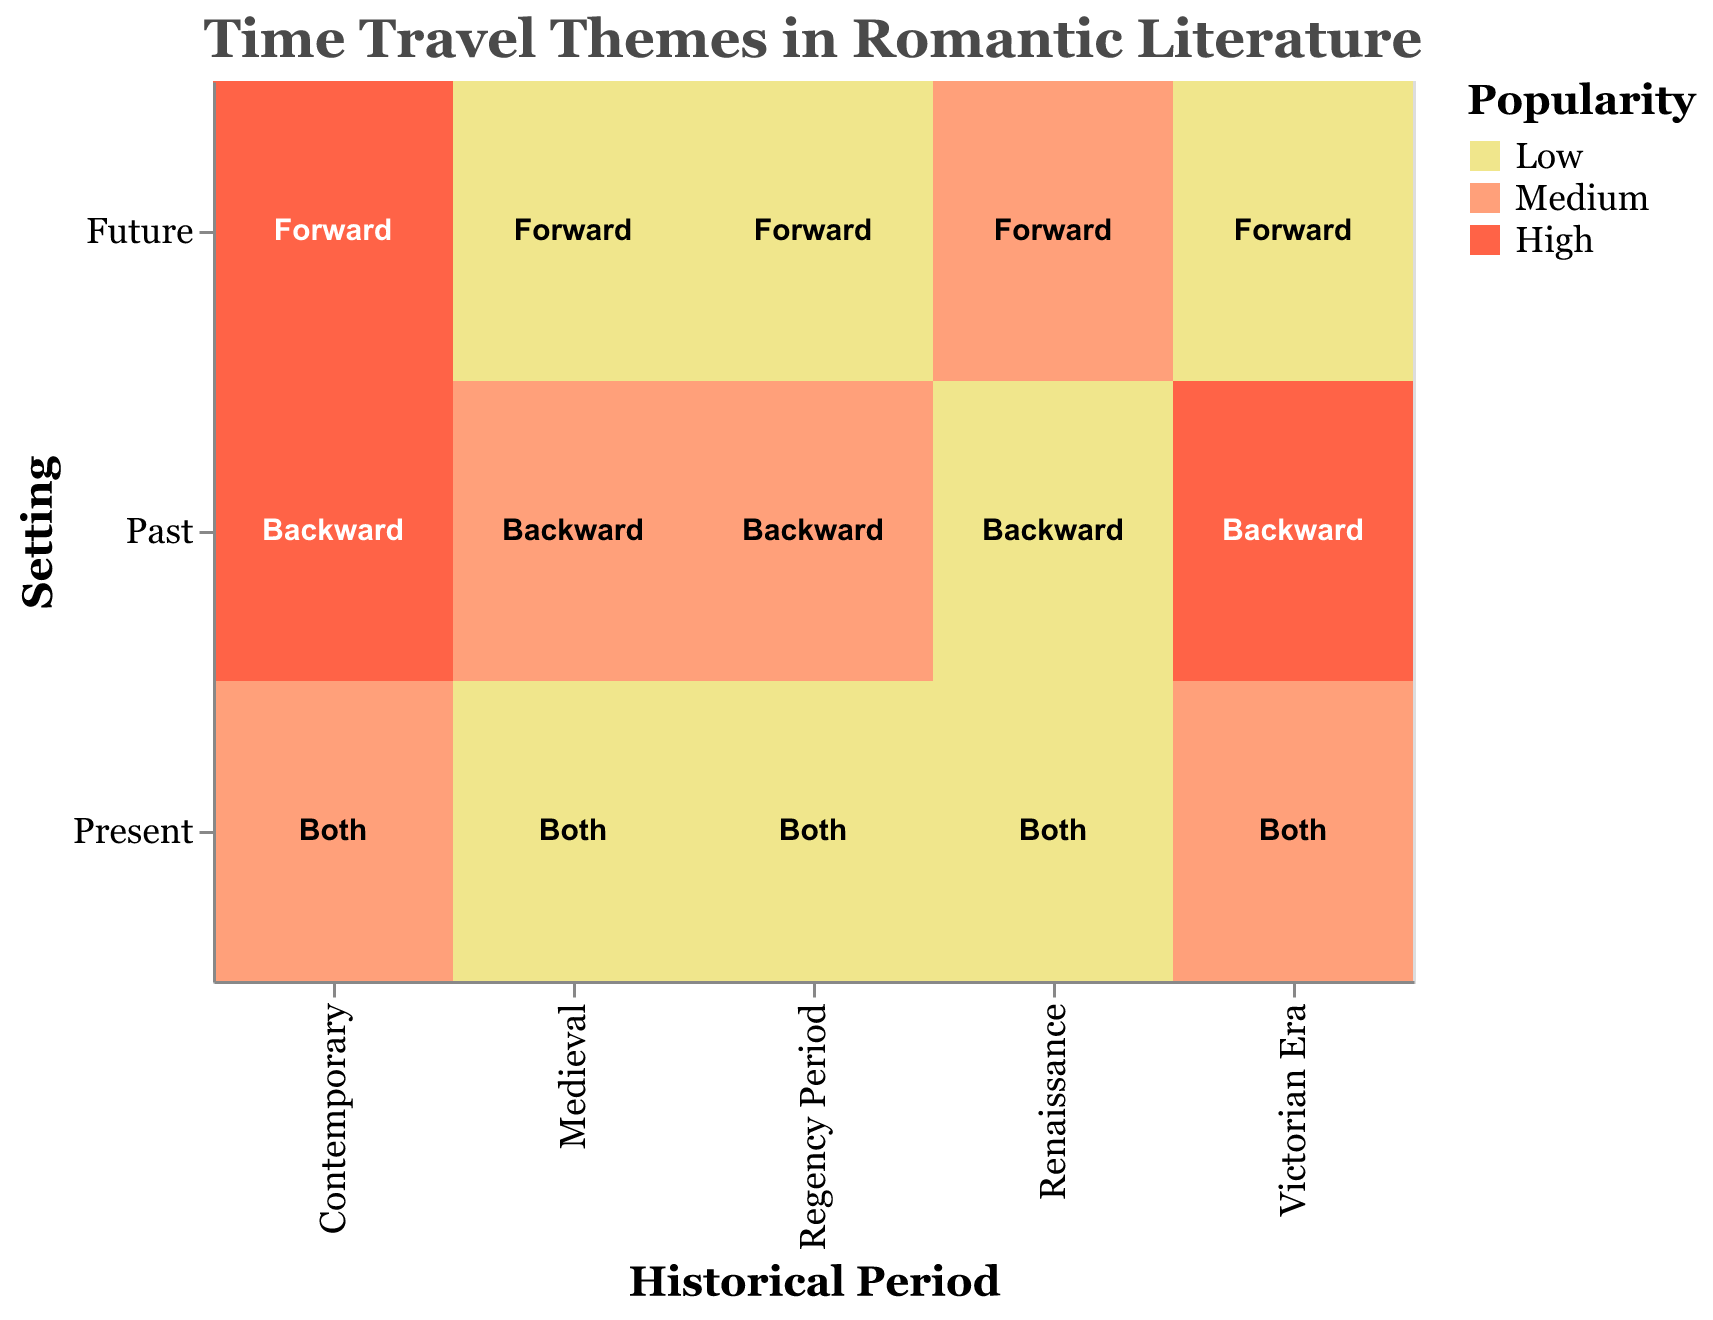How many historical periods are represented in the figure? The historical periods are represented along the x-axis. They are Victorian Era, Regency Period, Contemporary, Medieval, and Renaissance. Counting these periods gives us 5.
Answer: 5 Which historical period has the highest popularity for time travel in a forward direction? To find this, look at the color and text in the corresponding cells. Forward direction is represented by "Forward," and the highest popularity color is a darker shade (red). The Contemporary period shows a "High" popularity for forwarding direction.
Answer: Contemporary What is the unique time travel direction for the Renaissance period where the popularity reaches medium? Scan the Renaissance section for the popularity color indicating "Medium." The future setting is colored orange, indicating medium popularity, and the travel direction is forward.
Answer: Forward Which setting in the Regency period has the lowest popularity, and what is its time travel direction? Check the Regency period on the y-axis and identify the cells with the lightest color indicating "Low." Both the Future and Present settings have low popularity. They show "Forward" and "Both" directions, respectively.
Answer: Future, Forward and Present, Both Is there any period where the present setting has a high popularity for time travel in both directions? Check the cells under the present setting for a high popularity (darker red). None of the periods under the present setting display high popularity.
Answer: No How many combinations of historical periods and settings have medium popularity? Count the cells that are colored light orange (medium popularity) across all settings. The medium popularity combinations are:
  - Victorian Era, Both
  - Regency Period, Backward
  - Contemporary, Both
  - Medieval, Backward
  - Renaissance, Forward
There are 5 such combinations.
Answer: 5 Compare the popularity of time travel in the past setting for the Victorian Era and Medieval period. Which period has higher popularity? For the past setting, check the Victorian Era and Medieval period cells. Victorian Era is colored dark red (high), Medieval is light orange (medium). Hence, Victorian Era has higher popularity.
Answer: Victorian Era Which historical period has no high popularity across any setting? Look for historical periods that lack dark red cells. The periods with no high popularity across any setting are Regency Period, Medieval, and Renaissance.
Answer: Regency Period, Medieval, Renaissance What is the most common popularity level in the Medieval period? In the Medieval period, count the cells based on their popularity color. There are two low popularity cells (Future, Present) and one medium popularity cell (Past). Low popularity is most common.
Answer: Low 